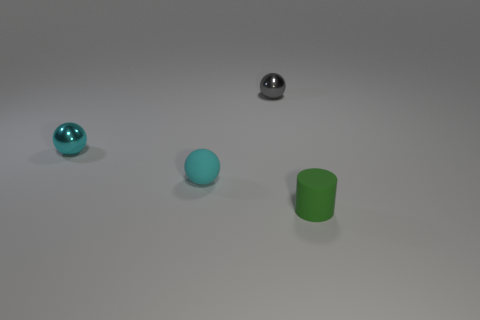Add 3 purple cylinders. How many objects exist? 7 Subtract all small gray balls. How many balls are left? 2 Subtract all gray spheres. How many spheres are left? 2 Subtract all green cylinders. How many cyan balls are left? 2 Subtract all spheres. How many objects are left? 1 Subtract all small gray spheres. Subtract all tiny brown matte balls. How many objects are left? 3 Add 3 tiny shiny spheres. How many tiny shiny spheres are left? 5 Add 2 yellow cylinders. How many yellow cylinders exist? 2 Subtract 0 brown balls. How many objects are left? 4 Subtract 2 spheres. How many spheres are left? 1 